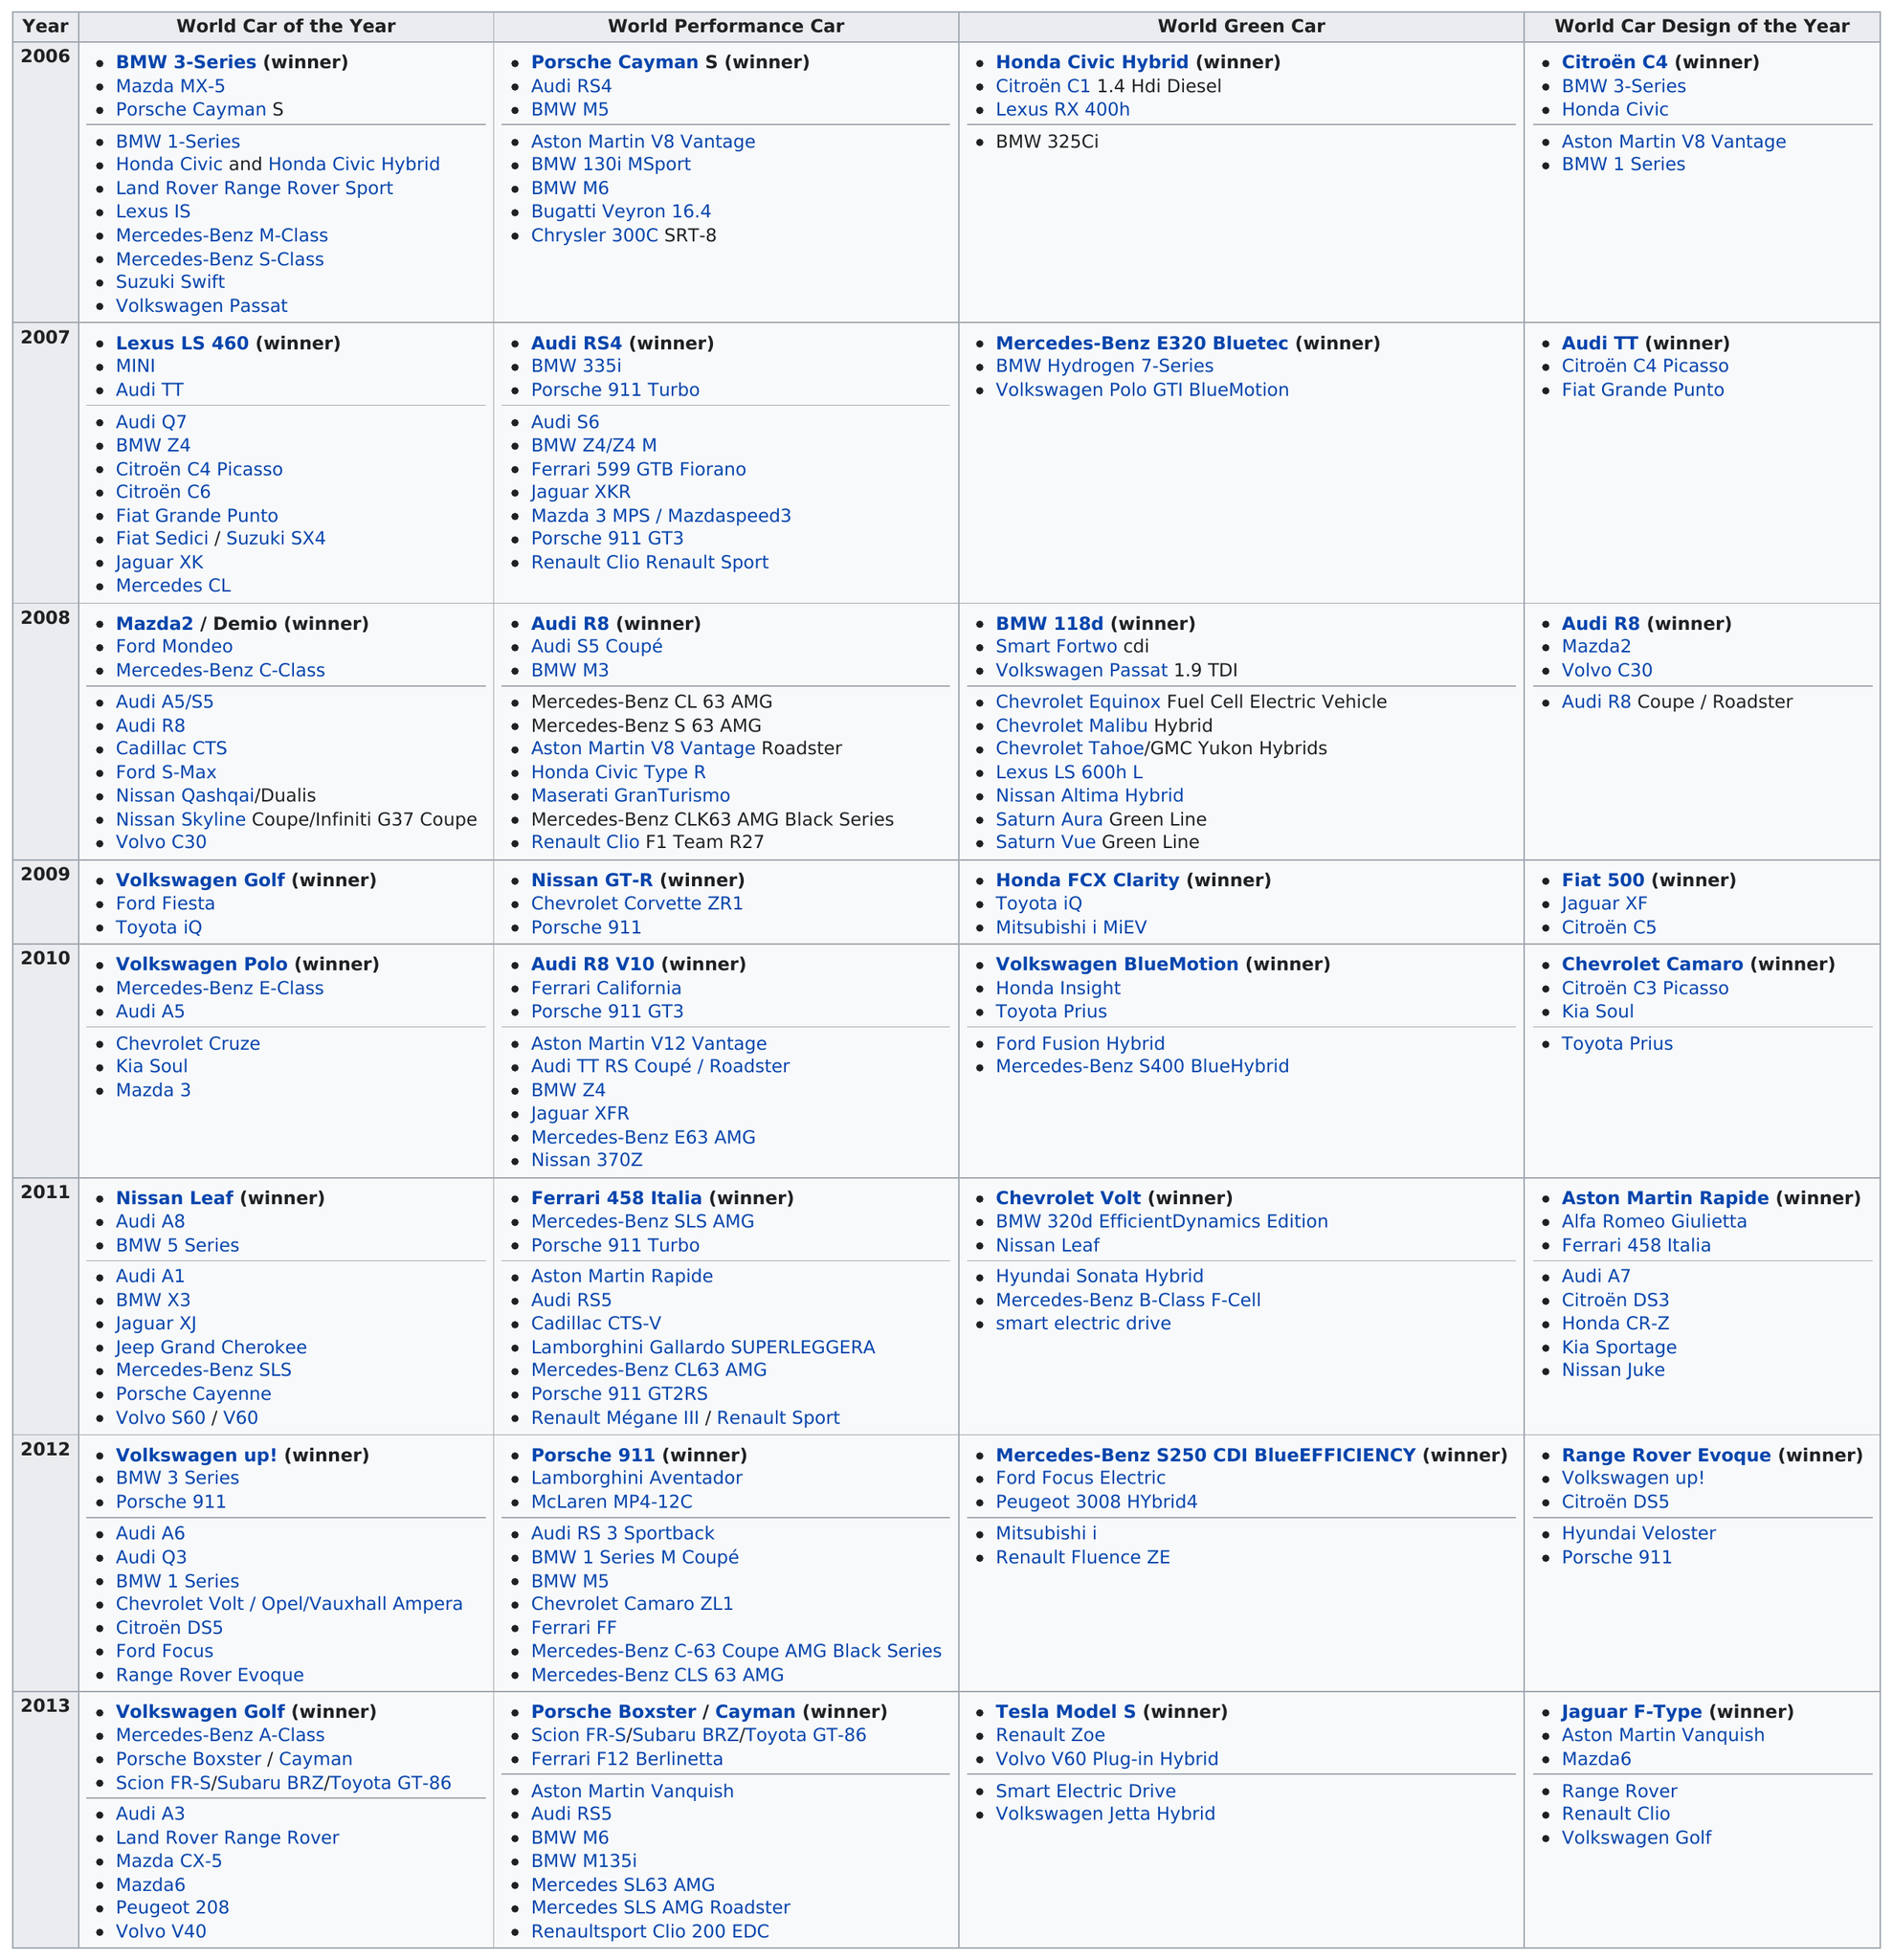Give some essential details in this illustration. As of 2007, there were 10 total world performance cars. In 2009, 3 world performance cars were entered. In 2008, the Audi R8 was recognized as the top car design of the year. On average, there are 4 winners per year. For how many consecutive years did Volkswagen win the World Car of the Year award? The answer is two. 